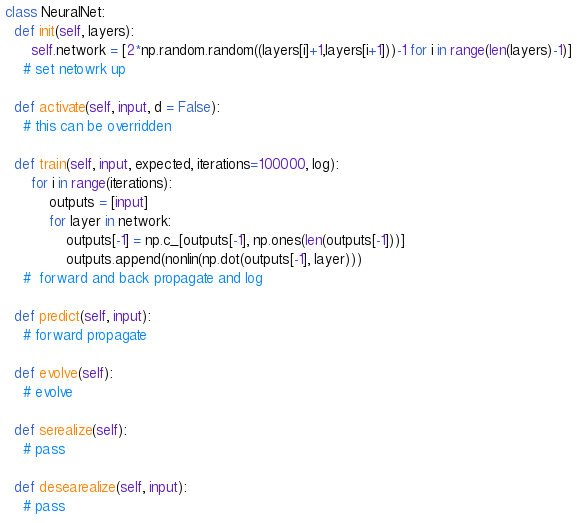<code> <loc_0><loc_0><loc_500><loc_500><_Python_>class NeuralNet:
  def init(self, layers):
      self.network = [2*np.random.random((layers[i]+1,layers[i+1]))-1 for i in range(len(layers)-1)]
    # set netowrk up

  def activate(self, input, d = False):
    # this can be overridden

  def train(self, input, expected, iterations=100000, log):
      for i in range(iterations):
          outputs = [input]
          for layer in network:
              outputs[-1] = np.c_[outputs[-1], np.ones(len(outputs[-1]))]
              outputs.append(nonlin(np.dot(outputs[-1], layer)))
    #  forward and back propagate and log

  def predict(self, input):
    # forward propagate

  def evolve(self):
    # evolve

  def serealize(self):
    # pass

  def desearealize(self, input):
    # pass
</code> 